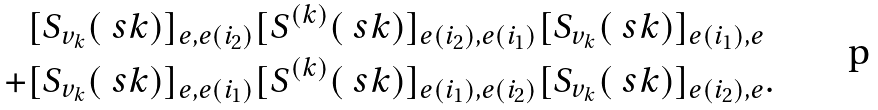Convert formula to latex. <formula><loc_0><loc_0><loc_500><loc_500>& [ S _ { v _ { k } } ( \ s k ) ] _ { e , e ( i _ { 2 } ) } [ S ^ { ( k ) } ( \ s k ) ] _ { e ( i _ { 2 } ) , e ( i _ { 1 } ) } [ S _ { v _ { k } } ( \ s k ) ] _ { e ( i _ { 1 } ) , e } \\ + & [ S _ { v _ { k } } ( \ s k ) ] _ { e , e ( i _ { 1 } ) } [ S ^ { ( k ) } ( \ s k ) ] _ { e ( i _ { 1 } ) , e ( i _ { 2 } ) } [ S _ { v _ { k } } ( \ s k ) ] _ { e ( i _ { 2 } ) , e } .</formula> 